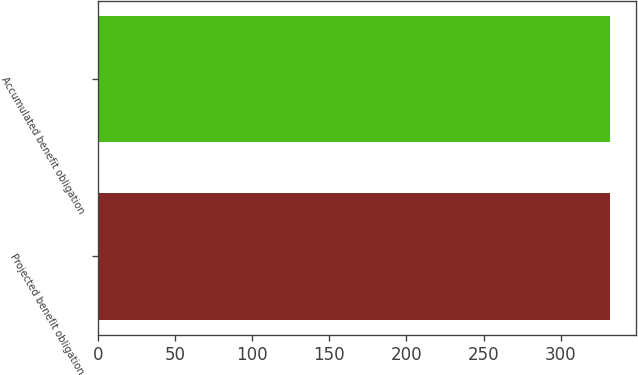<chart> <loc_0><loc_0><loc_500><loc_500><bar_chart><fcel>Projected benefit obligation<fcel>Accumulated benefit obligation<nl><fcel>332<fcel>332.1<nl></chart> 